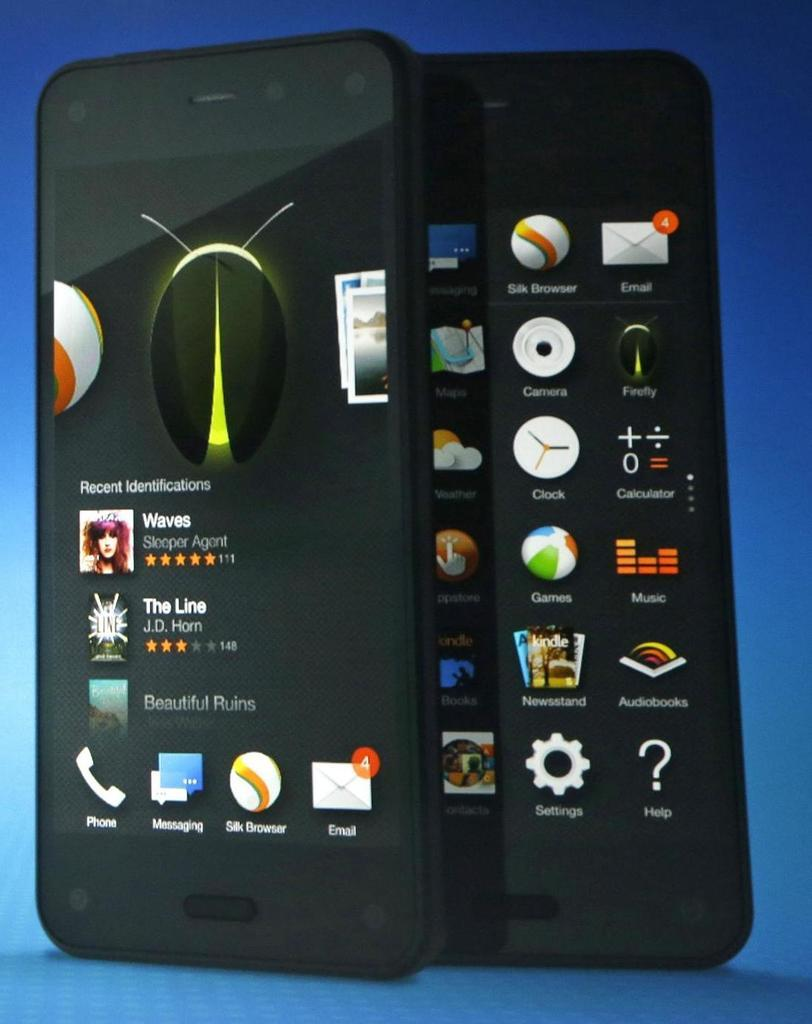<image>
Describe the image concisely. Two matching cell phones standing together and one has The Line on it. 